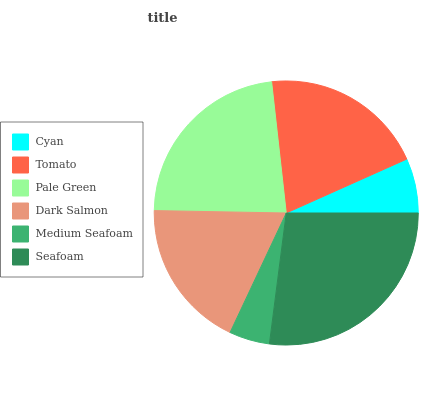Is Medium Seafoam the minimum?
Answer yes or no. Yes. Is Seafoam the maximum?
Answer yes or no. Yes. Is Tomato the minimum?
Answer yes or no. No. Is Tomato the maximum?
Answer yes or no. No. Is Tomato greater than Cyan?
Answer yes or no. Yes. Is Cyan less than Tomato?
Answer yes or no. Yes. Is Cyan greater than Tomato?
Answer yes or no. No. Is Tomato less than Cyan?
Answer yes or no. No. Is Tomato the high median?
Answer yes or no. Yes. Is Dark Salmon the low median?
Answer yes or no. Yes. Is Pale Green the high median?
Answer yes or no. No. Is Medium Seafoam the low median?
Answer yes or no. No. 